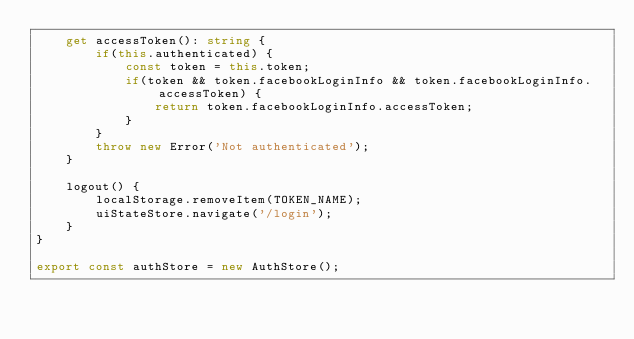Convert code to text. <code><loc_0><loc_0><loc_500><loc_500><_TypeScript_>    get accessToken(): string {
        if(this.authenticated) {
            const token = this.token;
            if(token && token.facebookLoginInfo && token.facebookLoginInfo.accessToken) {
                return token.facebookLoginInfo.accessToken;
            }
        }
        throw new Error('Not authenticated');
    }

    logout() {
        localStorage.removeItem(TOKEN_NAME);
        uiStateStore.navigate('/login');
    }
}

export const authStore = new AuthStore();
</code> 